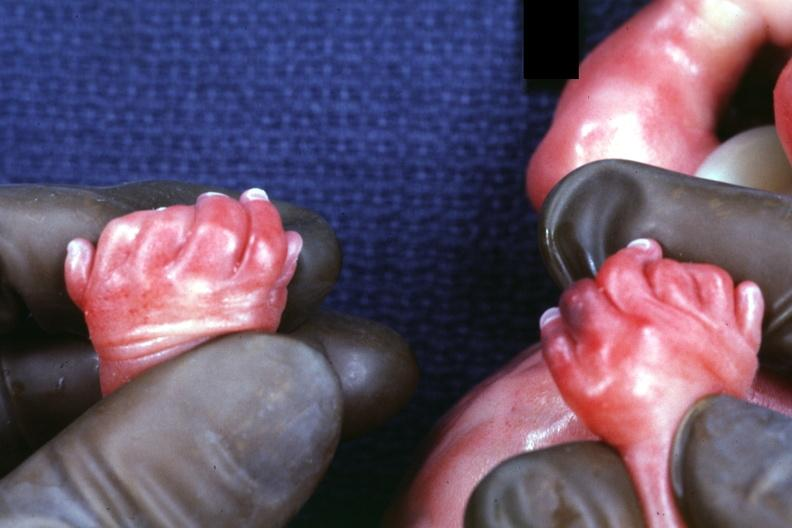s electron micrographs demonstrating fiber present?
Answer the question using a single word or phrase. Yes 